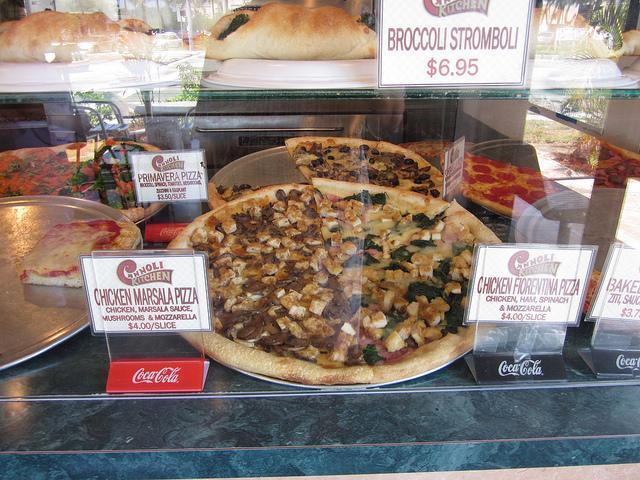How many pizzas are in the picture?
Give a very brief answer. 6. How many sandwiches can you see?
Give a very brief answer. 2. 